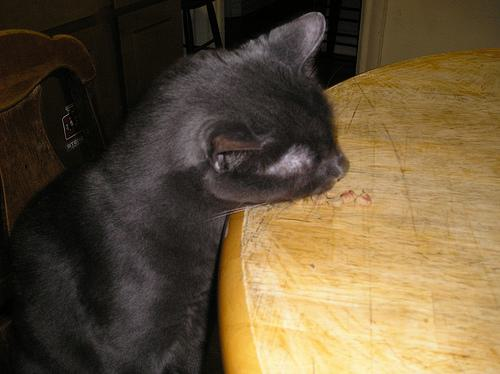What type of table is shown in the image? The table in the image seems to be a smaller wooden table, likely used for casual or personal use and not suitable for formal dining. 